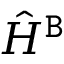Convert formula to latex. <formula><loc_0><loc_0><loc_500><loc_500>\hat { H } ^ { \tt B }</formula> 